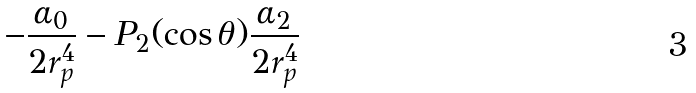Convert formula to latex. <formula><loc_0><loc_0><loc_500><loc_500>- \frac { \alpha _ { 0 } } { 2 r _ { p } ^ { 4 } } - P _ { 2 } ( \cos \theta ) \frac { \alpha _ { 2 } } { 2 r _ { p } ^ { 4 } }</formula> 